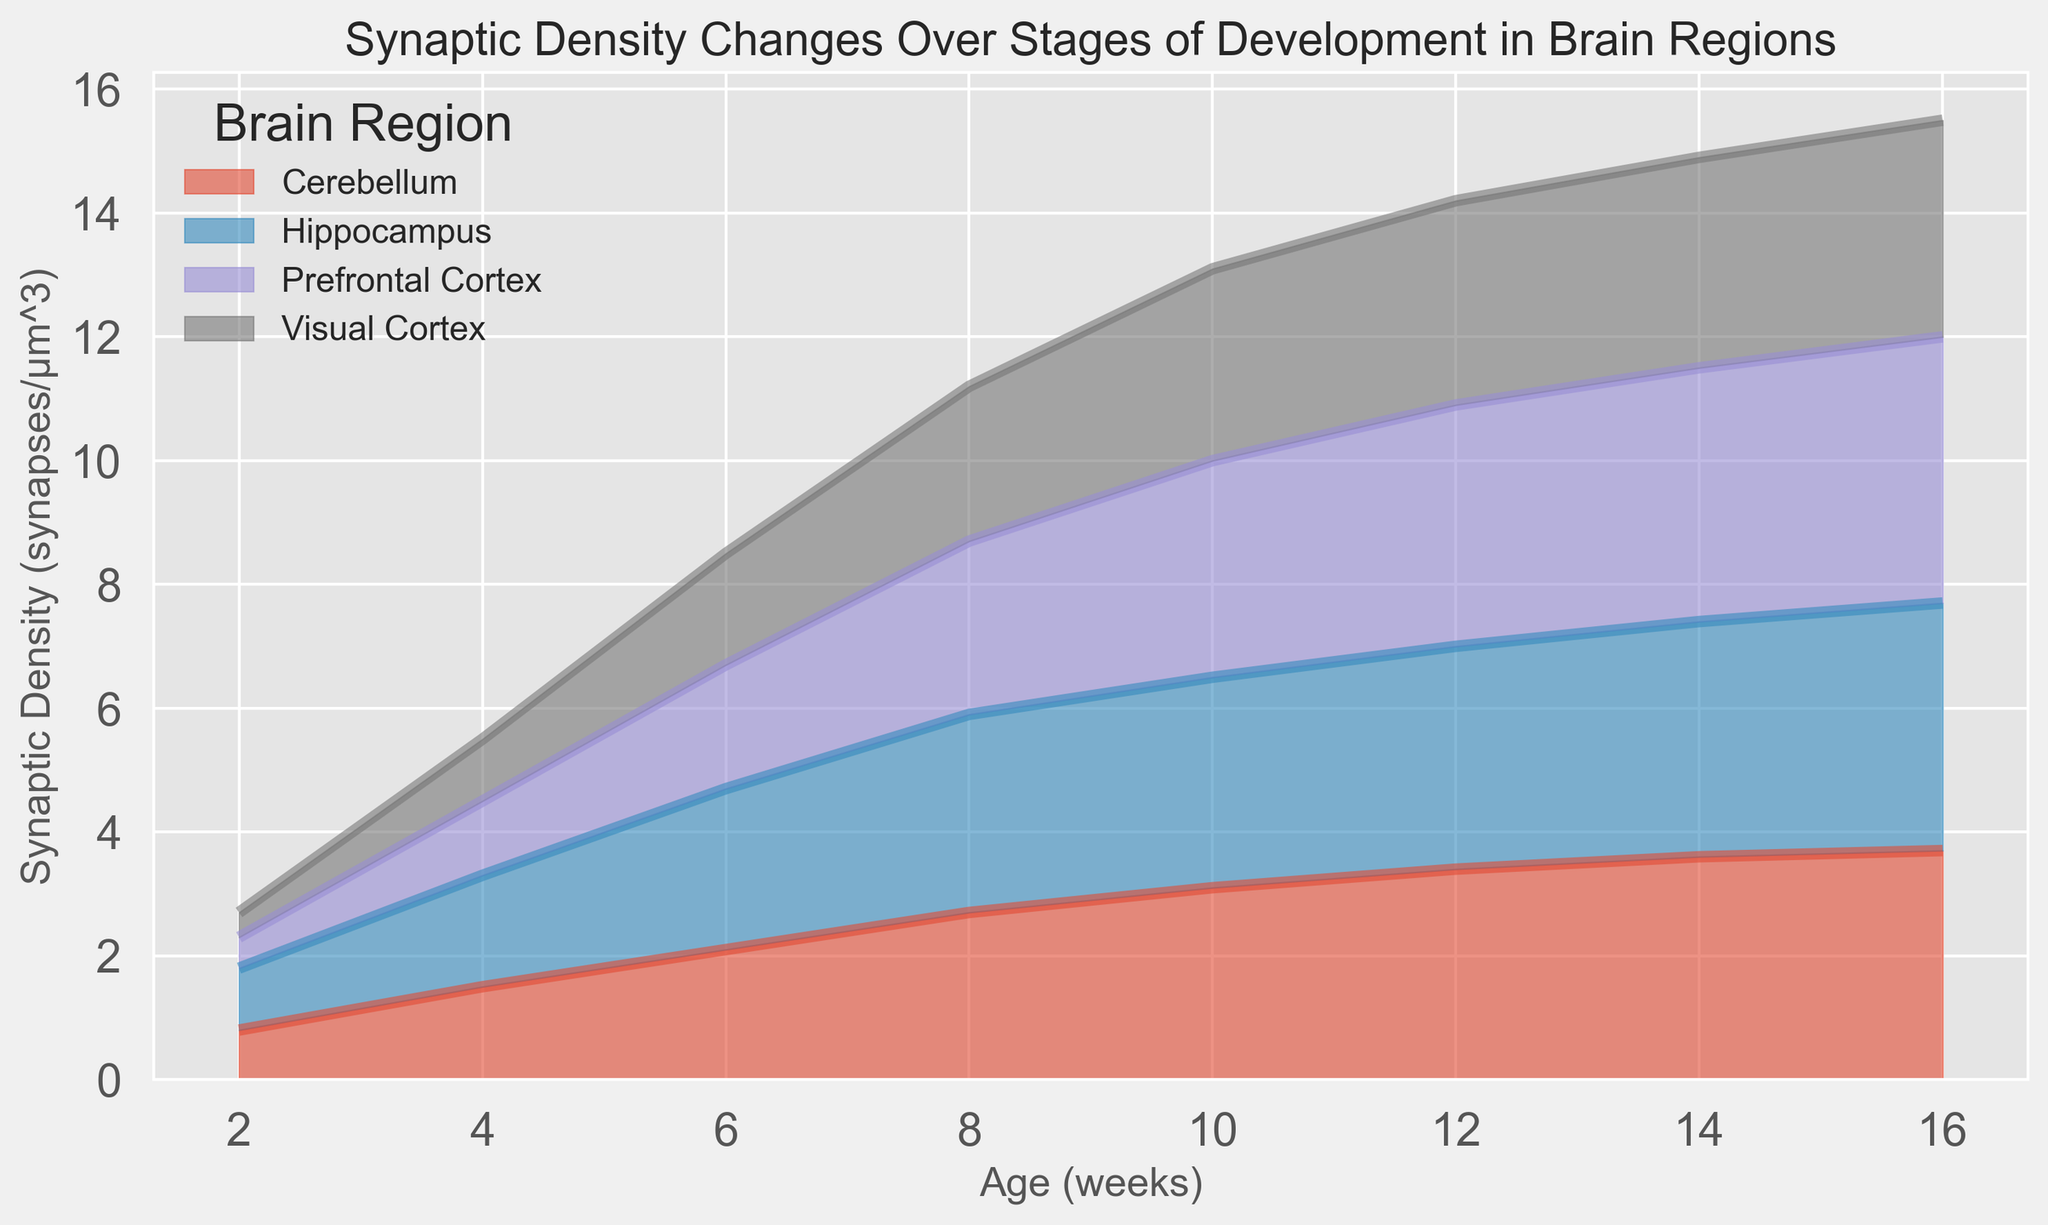Which brain region shows the highest synaptic density at 10 weeks? The plot shows different trends for synaptic density in various brain regions. By checking the heights of the areas for each region at the 10-week mark, we see that the Prefrontal Cortex has the tallest height, indicating the highest density.
Answer: Prefrontal Cortex Between the Prefrontal Cortex and Visual Cortex, which region has a greater increase in synaptic density from 2 to 8 weeks? The synaptic density for the Prefrontal Cortex increases from 0.5 at 2 weeks to 2.8 at 8 weeks, a difference of 2.3. For the Visual Cortex, it increases from 0.4 to 2.5, a difference of 2.1. Comparing these differences, the Prefrontal Cortex has a greater increase.
Answer: Prefrontal Cortex At what age does the Hippocampus reach a synaptic density of approximately 3.4 synapses/µm^3? Observing the plot for the Hippocampus, we see that its area height reaches around 3.4 at the 10-week mark. This is confirmed by the gradual rise in synaptic density shown in the plot.
Answer: 10 weeks By how much does synaptic density increase in the Cerebellum from 6 to 14 weeks? In the plot, the synaptic density for the Cerebellum is 2.1 at 6 weeks and 3.6 at 14 weeks. The increase is calculated as 3.6 - 2.1 = 1.5 synapses/µm^3.
Answer: 1.5 synapses/µm^3 Which brain region shows the least synaptic density at 16 weeks? At the 16-week mark, the Visual Cortex has the shortest height among all regions in the plot, indicating the least density.
Answer: Visual Cortex Compare the synaptic density trends of the Prefrontal Cortex and Hippocampus from 4 to 12 weeks. From 4 to 12 weeks, the Prefrontal Cortex shows a steady increase in synaptic density from 1.2 to 3.9. The Hippocampus also increases but at a slightly lower rate, from 1.8 to 3.6. The overall trend for both shows a rise, but the Prefrontal Cortex increases more steeply.
Answer: Prefrontal Cortex shows a steeper increase What is the average synaptic density in the Visual Cortex at 2, 8, and 16 weeks? The synaptic densities are 0.4 at 2 weeks, 2.5 at 8 weeks, and 3.5 at 16 weeks. Adding these values (0.4 + 2.5 + 3.5 = 6.4) and dividing by the number of observations (3) gives an average of approximately 2.13 synapses/µm^3.
Answer: 2.13 synapses/µm^3 Is the trend in synaptic density for the Cerebellum consistent over the 16 weeks? Observing the plot for the Cerebellum's area height, it shows a consistent upward trend over the 16 weeks without any decreases, indicating a consistent increase.
Answer: Yes Does any brain region show a decrease in synaptic density at any point on the plot? By examining the plot, we see that all regions show either a steady or increasing trend without any dips, indicating no decrease in synaptic density at any point.
Answer: No 